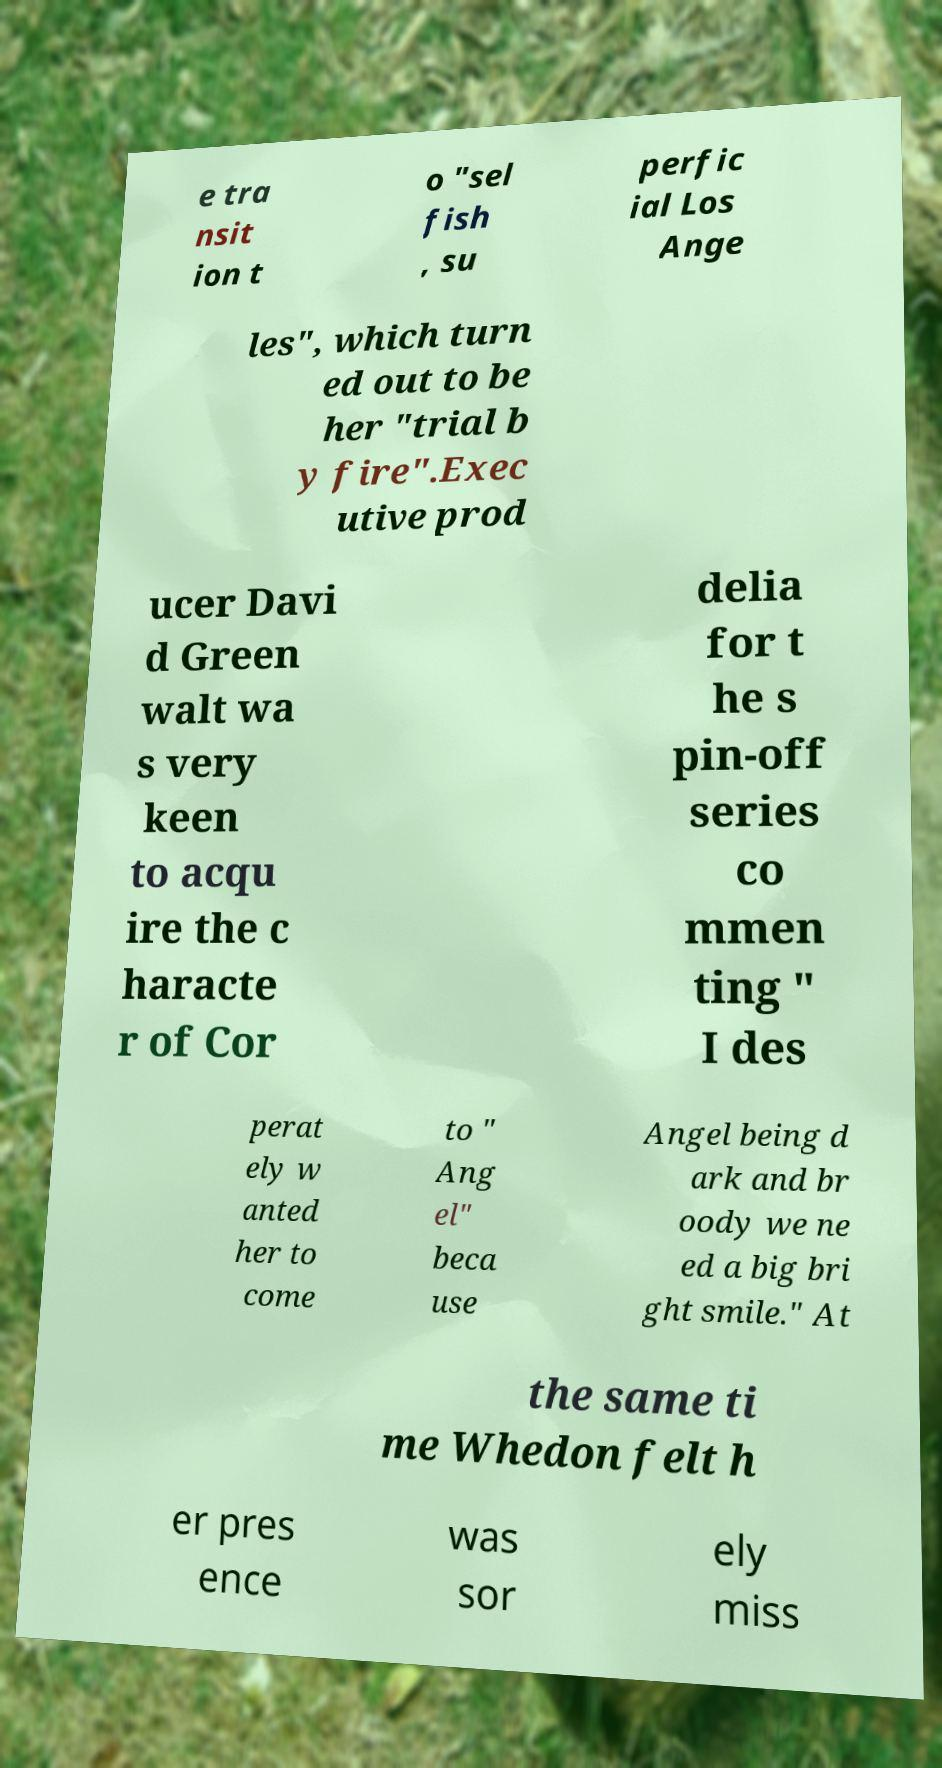Please read and relay the text visible in this image. What does it say? e tra nsit ion t o "sel fish , su perfic ial Los Ange les", which turn ed out to be her "trial b y fire".Exec utive prod ucer Davi d Green walt wa s very keen to acqu ire the c haracte r of Cor delia for t he s pin-off series co mmen ting " I des perat ely w anted her to come to " Ang el" beca use Angel being d ark and br oody we ne ed a big bri ght smile." At the same ti me Whedon felt h er pres ence was sor ely miss 